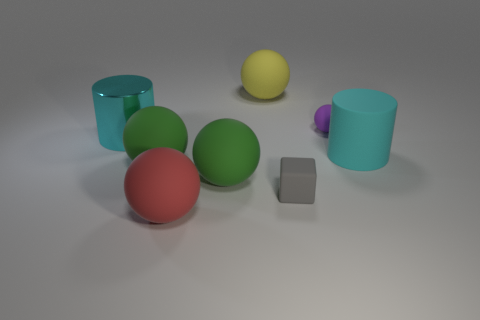Subtract all purple balls. How many balls are left? 4 Subtract all red balls. How many balls are left? 4 Subtract 1 balls. How many balls are left? 4 Subtract all blue spheres. Subtract all cyan cylinders. How many spheres are left? 5 Add 1 large yellow matte balls. How many objects exist? 9 Subtract all cylinders. How many objects are left? 6 Subtract all small matte spheres. Subtract all yellow matte balls. How many objects are left? 6 Add 6 yellow things. How many yellow things are left? 7 Add 5 cyan metal cylinders. How many cyan metal cylinders exist? 6 Subtract 1 gray blocks. How many objects are left? 7 